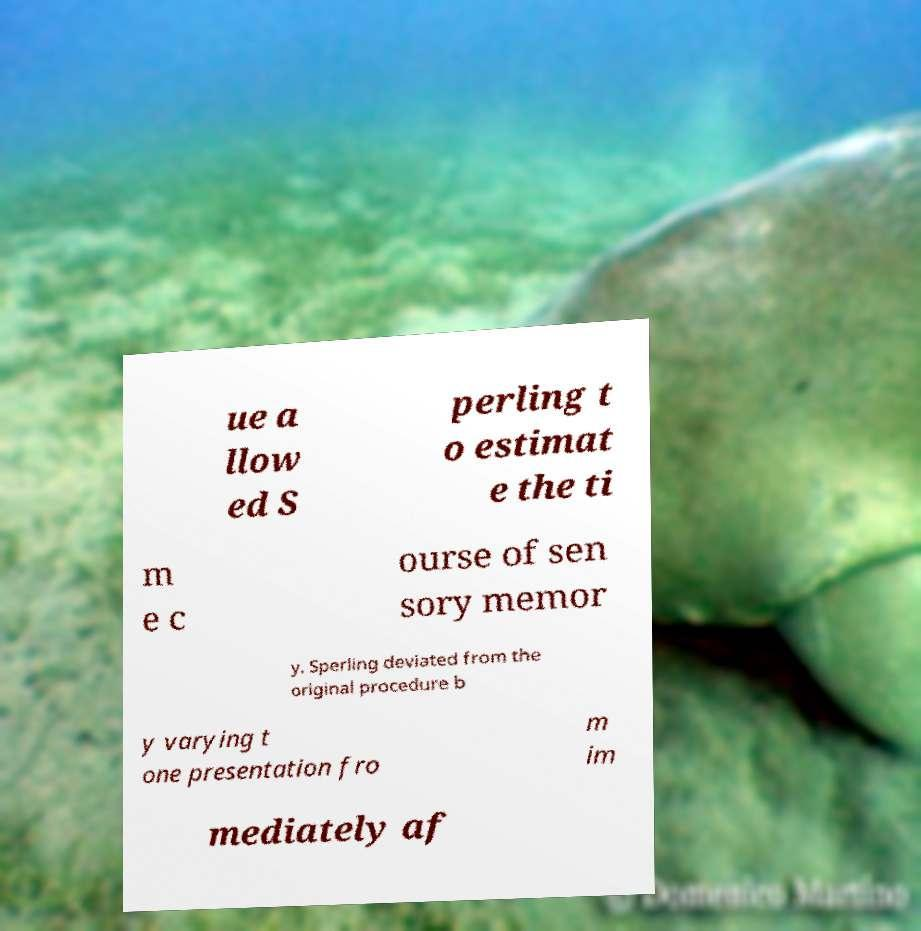Can you accurately transcribe the text from the provided image for me? ue a llow ed S perling t o estimat e the ti m e c ourse of sen sory memor y. Sperling deviated from the original procedure b y varying t one presentation fro m im mediately af 